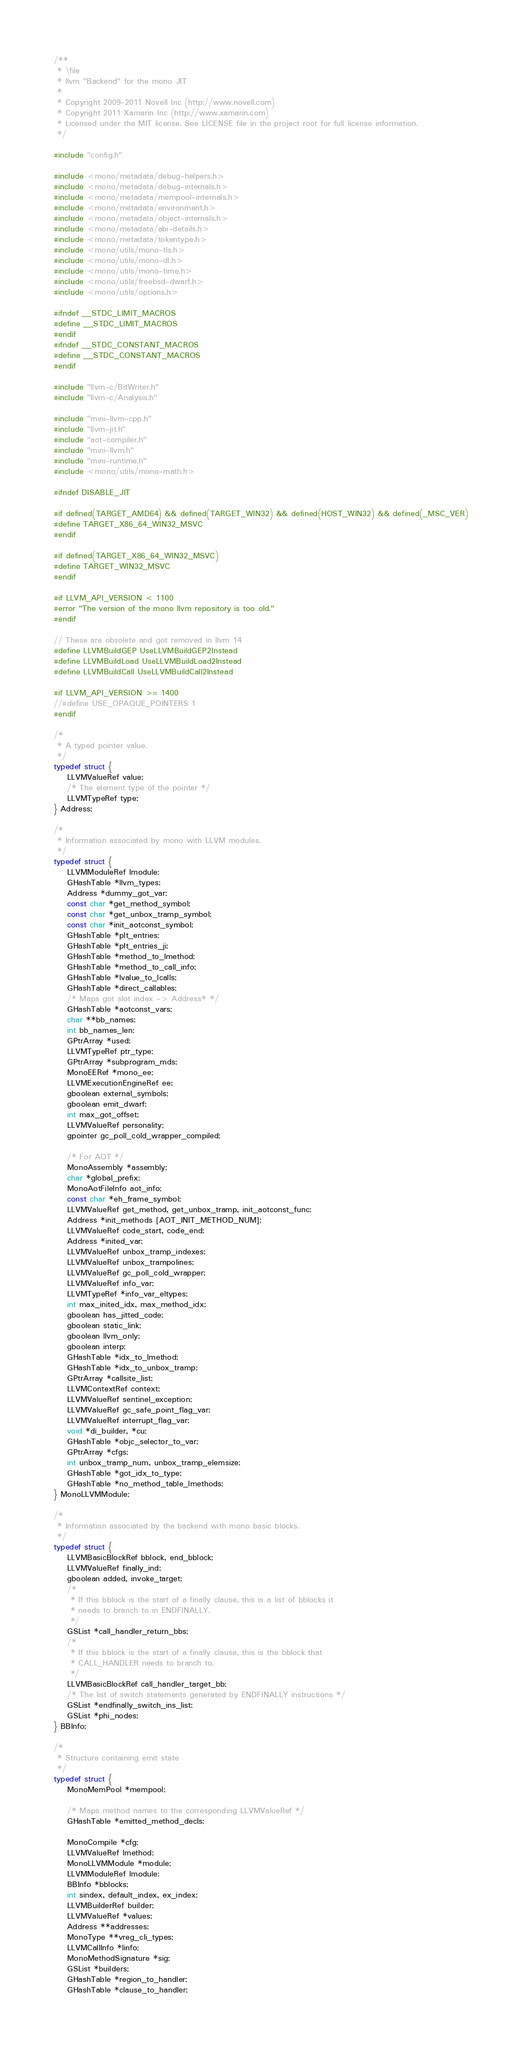Convert code to text. <code><loc_0><loc_0><loc_500><loc_500><_C_>/**
 * \file
 * llvm "Backend" for the mono JIT
 *
 * Copyright 2009-2011 Novell Inc (http://www.novell.com)
 * Copyright 2011 Xamarin Inc (http://www.xamarin.com)
 * Licensed under the MIT license. See LICENSE file in the project root for full license information.
 */

#include "config.h"

#include <mono/metadata/debug-helpers.h>
#include <mono/metadata/debug-internals.h>
#include <mono/metadata/mempool-internals.h>
#include <mono/metadata/environment.h>
#include <mono/metadata/object-internals.h>
#include <mono/metadata/abi-details.h>
#include <mono/metadata/tokentype.h>
#include <mono/utils/mono-tls.h>
#include <mono/utils/mono-dl.h>
#include <mono/utils/mono-time.h>
#include <mono/utils/freebsd-dwarf.h>
#include <mono/utils/options.h>

#ifndef __STDC_LIMIT_MACROS
#define __STDC_LIMIT_MACROS
#endif
#ifndef __STDC_CONSTANT_MACROS
#define __STDC_CONSTANT_MACROS
#endif

#include "llvm-c/BitWriter.h"
#include "llvm-c/Analysis.h"

#include "mini-llvm-cpp.h"
#include "llvm-jit.h"
#include "aot-compiler.h"
#include "mini-llvm.h"
#include "mini-runtime.h"
#include <mono/utils/mono-math.h>

#ifndef DISABLE_JIT

#if defined(TARGET_AMD64) && defined(TARGET_WIN32) && defined(HOST_WIN32) && defined(_MSC_VER)
#define TARGET_X86_64_WIN32_MSVC
#endif

#if defined(TARGET_X86_64_WIN32_MSVC)
#define TARGET_WIN32_MSVC
#endif

#if LLVM_API_VERSION < 1100
#error "The version of the mono llvm repository is too old."
#endif

// These are obsolete and got removed in llvm 14
#define LLVMBuildGEP UseLLVMBuildGEP2Instead
#define LLVMBuildLoad UseLLVMBuildLoad2Instead
#define LLVMBuildCall UseLLVMBuildCall2Instead

#if LLVM_API_VERSION >= 1400
//#define USE_OPAQUE_POINTERS 1
#endif

/*
 * A typed pointer value.
 */
typedef struct {
	LLVMValueRef value;
	/* The element type of the pointer */
	LLVMTypeRef type;
} Address;

/*
 * Information associated by mono with LLVM modules.
 */
typedef struct {
	LLVMModuleRef lmodule;
	GHashTable *llvm_types;
	Address *dummy_got_var;
	const char *get_method_symbol;
	const char *get_unbox_tramp_symbol;
	const char *init_aotconst_symbol;
	GHashTable *plt_entries;
	GHashTable *plt_entries_ji;
	GHashTable *method_to_lmethod;
	GHashTable *method_to_call_info;
	GHashTable *lvalue_to_lcalls;
	GHashTable *direct_callables;
	/* Maps got slot index -> Address* */
	GHashTable *aotconst_vars;
	char **bb_names;
	int bb_names_len;
	GPtrArray *used;
	LLVMTypeRef ptr_type;
	GPtrArray *subprogram_mds;
	MonoEERef *mono_ee;
	LLVMExecutionEngineRef ee;
	gboolean external_symbols;
	gboolean emit_dwarf;
	int max_got_offset;
	LLVMValueRef personality;
	gpointer gc_poll_cold_wrapper_compiled;

	/* For AOT */
	MonoAssembly *assembly;
	char *global_prefix;
	MonoAotFileInfo aot_info;
	const char *eh_frame_symbol;
	LLVMValueRef get_method, get_unbox_tramp, init_aotconst_func;
	Address *init_methods [AOT_INIT_METHOD_NUM];
	LLVMValueRef code_start, code_end;
	Address *inited_var;
	LLVMValueRef unbox_tramp_indexes;
	LLVMValueRef unbox_trampolines;
	LLVMValueRef gc_poll_cold_wrapper;
	LLVMValueRef info_var;
	LLVMTypeRef *info_var_eltypes;
	int max_inited_idx, max_method_idx;
	gboolean has_jitted_code;
	gboolean static_link;
	gboolean llvm_only;
	gboolean interp;
	GHashTable *idx_to_lmethod;
	GHashTable *idx_to_unbox_tramp;
	GPtrArray *callsite_list;
	LLVMContextRef context;
	LLVMValueRef sentinel_exception;
	LLVMValueRef gc_safe_point_flag_var;
	LLVMValueRef interrupt_flag_var;
	void *di_builder, *cu;
	GHashTable *objc_selector_to_var;
	GPtrArray *cfgs;
	int unbox_tramp_num, unbox_tramp_elemsize;
	GHashTable *got_idx_to_type;
	GHashTable *no_method_table_lmethods;
} MonoLLVMModule;

/*
 * Information associated by the backend with mono basic blocks.
 */
typedef struct {
	LLVMBasicBlockRef bblock, end_bblock;
	LLVMValueRef finally_ind;
	gboolean added, invoke_target;
	/*
	 * If this bblock is the start of a finally clause, this is a list of bblocks it
	 * needs to branch to in ENDFINALLY.
	 */
	GSList *call_handler_return_bbs;
	/*
	 * If this bblock is the start of a finally clause, this is the bblock that
	 * CALL_HANDLER needs to branch to.
	 */
	LLVMBasicBlockRef call_handler_target_bb;
	/* The list of switch statements generated by ENDFINALLY instructions */
	GSList *endfinally_switch_ins_list;
	GSList *phi_nodes;
} BBInfo;

/*
 * Structure containing emit state
 */
typedef struct {
	MonoMemPool *mempool;

	/* Maps method names to the corresponding LLVMValueRef */
	GHashTable *emitted_method_decls;

	MonoCompile *cfg;
	LLVMValueRef lmethod;
	MonoLLVMModule *module;
	LLVMModuleRef lmodule;
	BBInfo *bblocks;
	int sindex, default_index, ex_index;
	LLVMBuilderRef builder;
	LLVMValueRef *values;
	Address **addresses;
	MonoType **vreg_cli_types;
	LLVMCallInfo *linfo;
	MonoMethodSignature *sig;
	GSList *builders;
	GHashTable *region_to_handler;
	GHashTable *clause_to_handler;</code> 